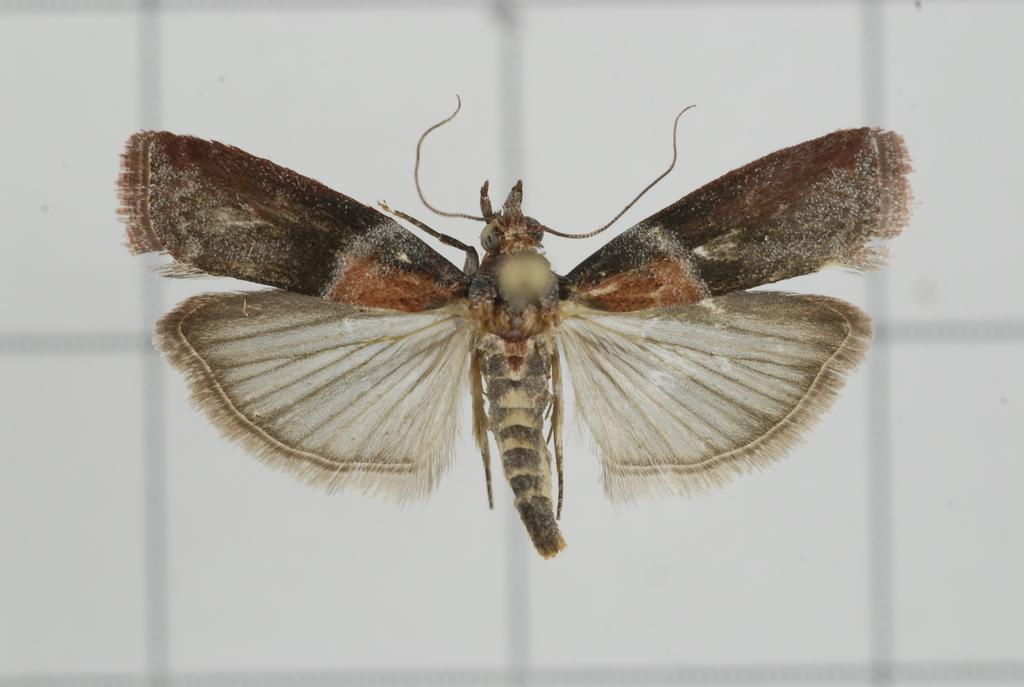What type of creature can be seen in the image? There is an insect in the image. What color is the insect in the image? The insect is brown in color. What type of honey is the insect producing in the image? There is no honey or indication of honey production in the image; it only features an insect. 